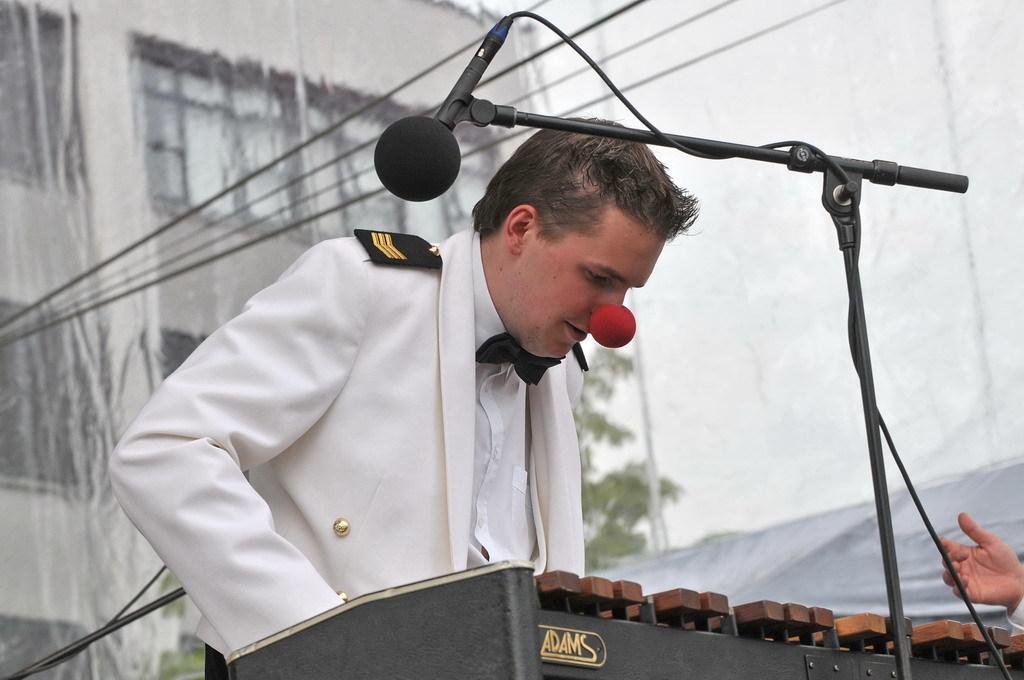Could you give a brief overview of what you see in this image? This image is taken outdoors. At the bottom of the image there is a podium with a mic. In the middle of the image a man is standing and he has worn a joker nose on his nose. On the right side of the image there is a person. In the background there is a poster and there are a few wires. 